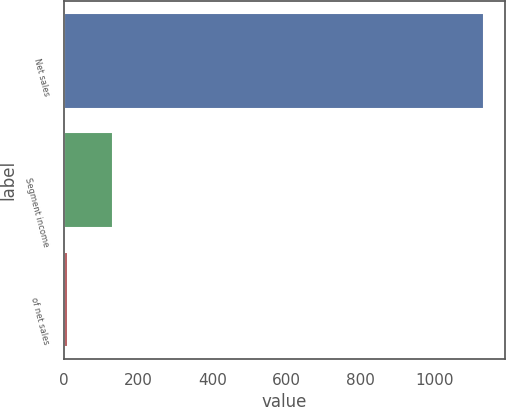<chart> <loc_0><loc_0><loc_500><loc_500><bar_chart><fcel>Net sales<fcel>Segment income<fcel>of net sales<nl><fcel>1131.6<fcel>132.3<fcel>11.7<nl></chart> 